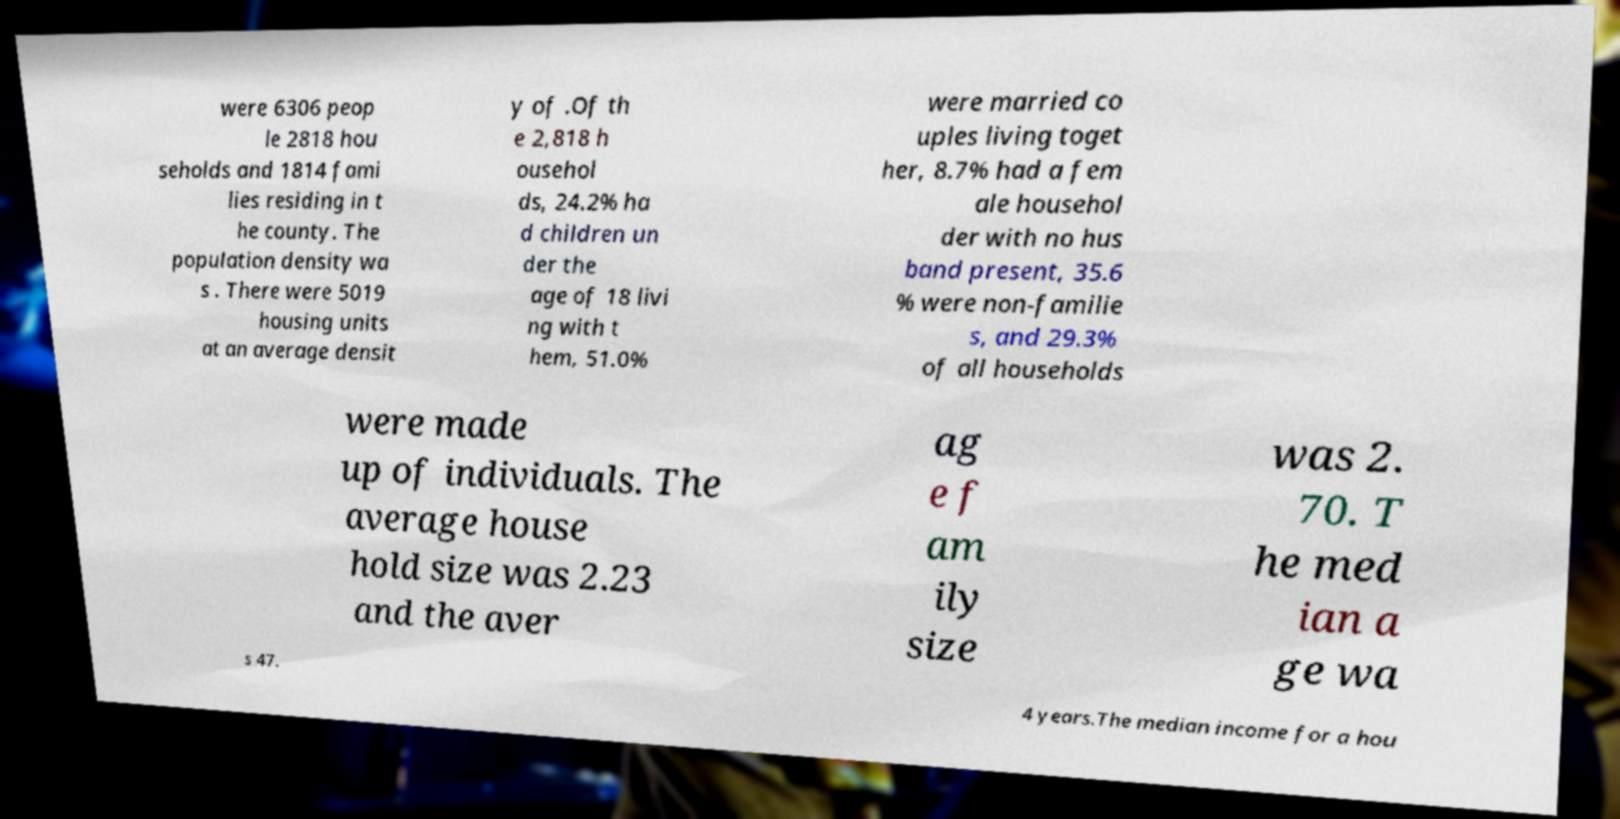I need the written content from this picture converted into text. Can you do that? were 6306 peop le 2818 hou seholds and 1814 fami lies residing in t he county. The population density wa s . There were 5019 housing units at an average densit y of .Of th e 2,818 h ousehol ds, 24.2% ha d children un der the age of 18 livi ng with t hem, 51.0% were married co uples living toget her, 8.7% had a fem ale househol der with no hus band present, 35.6 % were non-familie s, and 29.3% of all households were made up of individuals. The average house hold size was 2.23 and the aver ag e f am ily size was 2. 70. T he med ian a ge wa s 47. 4 years.The median income for a hou 